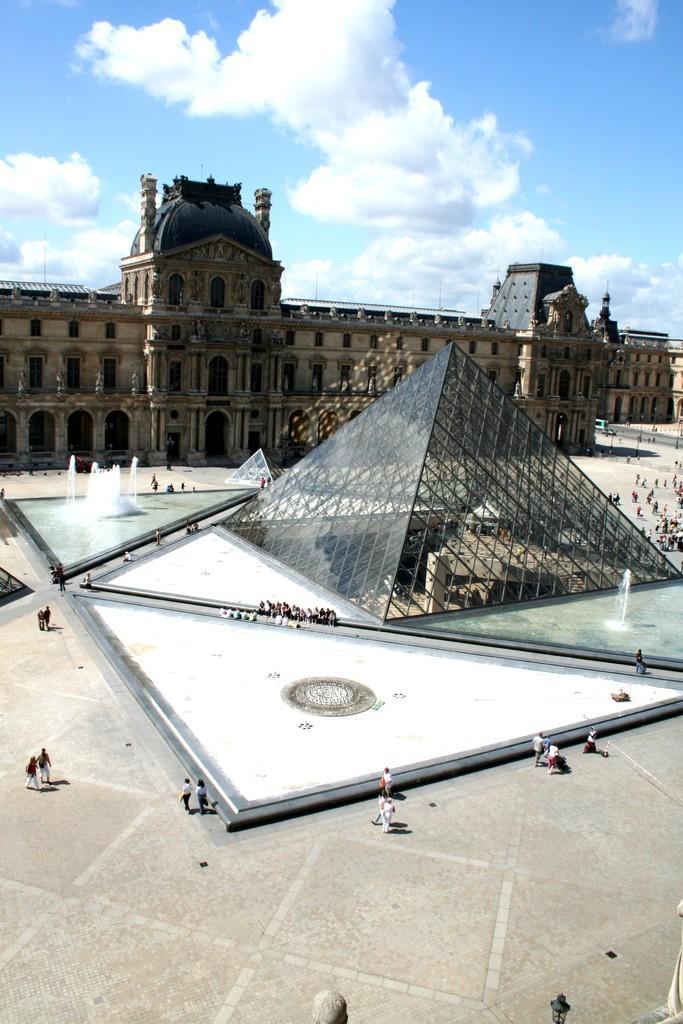Could you give a brief overview of what you see in this image? In this image we can see buildings, fountains, lights, and a sculpture, there are some persons, and a glass pyramid in the middle, also we can see the sky. 